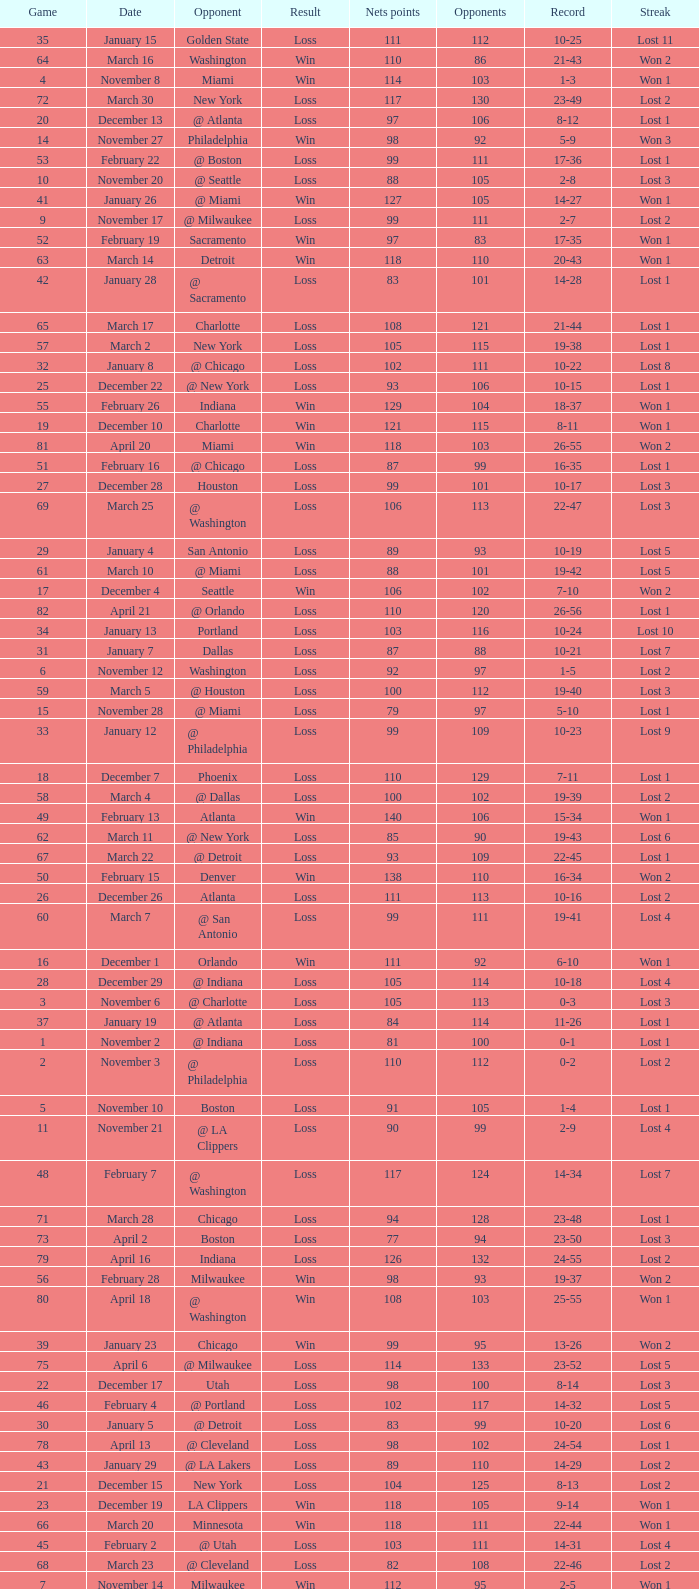In which game did the opponent score more than 103 and the record was 1-3? None. 